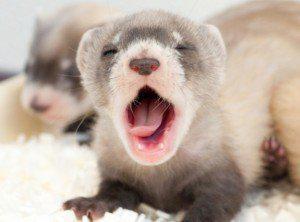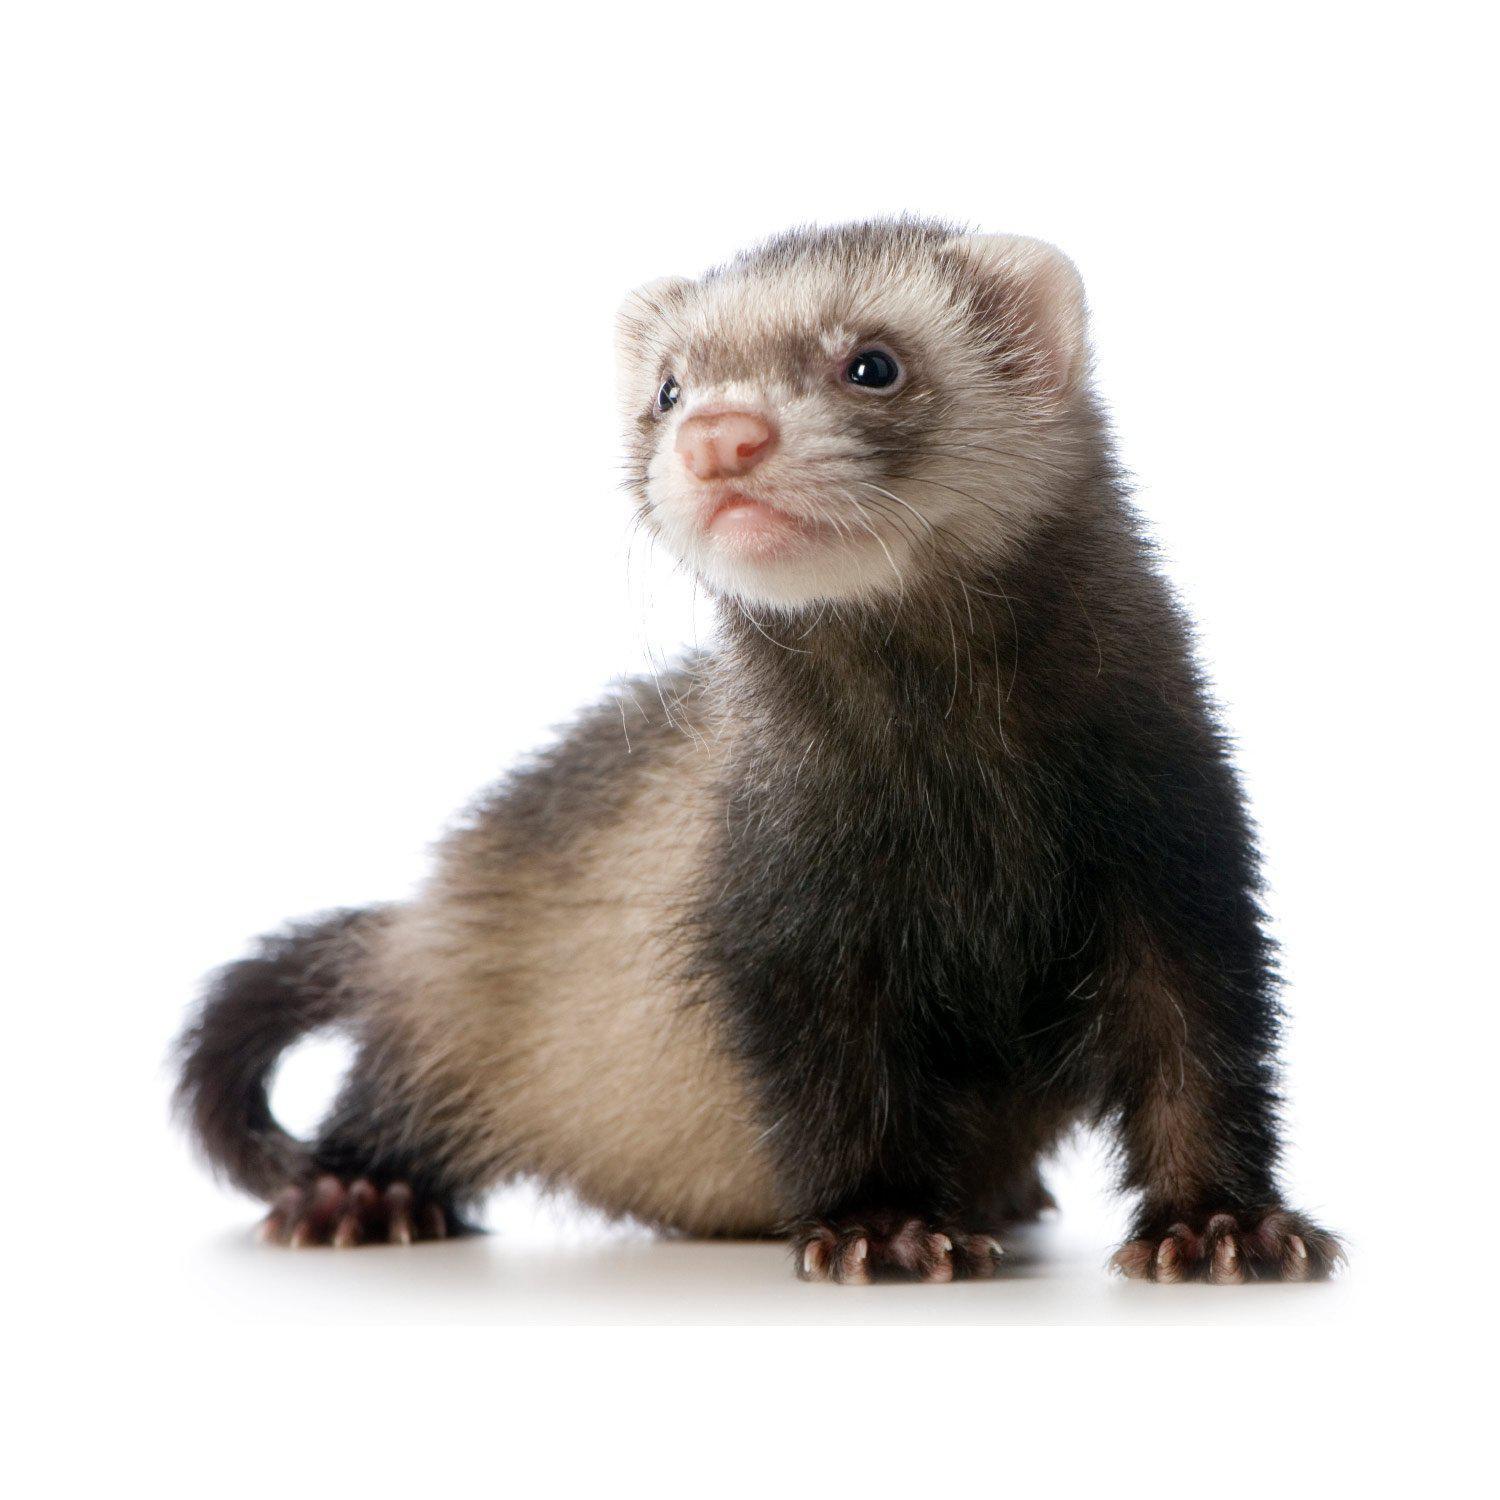The first image is the image on the left, the second image is the image on the right. Given the left and right images, does the statement "at least one animal has its mouth open" hold true? Answer yes or no. Yes. 